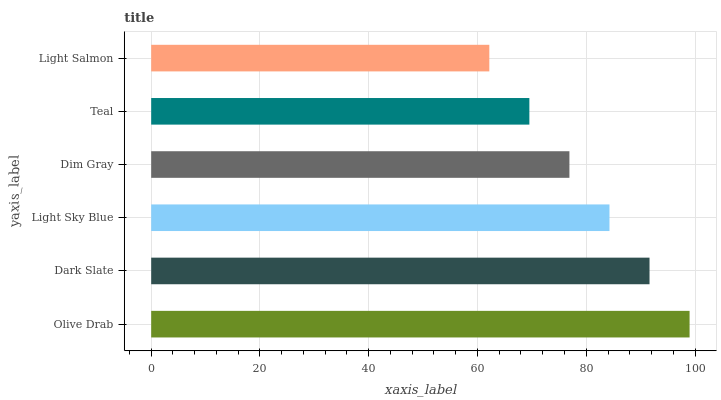Is Light Salmon the minimum?
Answer yes or no. Yes. Is Olive Drab the maximum?
Answer yes or no. Yes. Is Dark Slate the minimum?
Answer yes or no. No. Is Dark Slate the maximum?
Answer yes or no. No. Is Olive Drab greater than Dark Slate?
Answer yes or no. Yes. Is Dark Slate less than Olive Drab?
Answer yes or no. Yes. Is Dark Slate greater than Olive Drab?
Answer yes or no. No. Is Olive Drab less than Dark Slate?
Answer yes or no. No. Is Light Sky Blue the high median?
Answer yes or no. Yes. Is Dim Gray the low median?
Answer yes or no. Yes. Is Olive Drab the high median?
Answer yes or no. No. Is Olive Drab the low median?
Answer yes or no. No. 